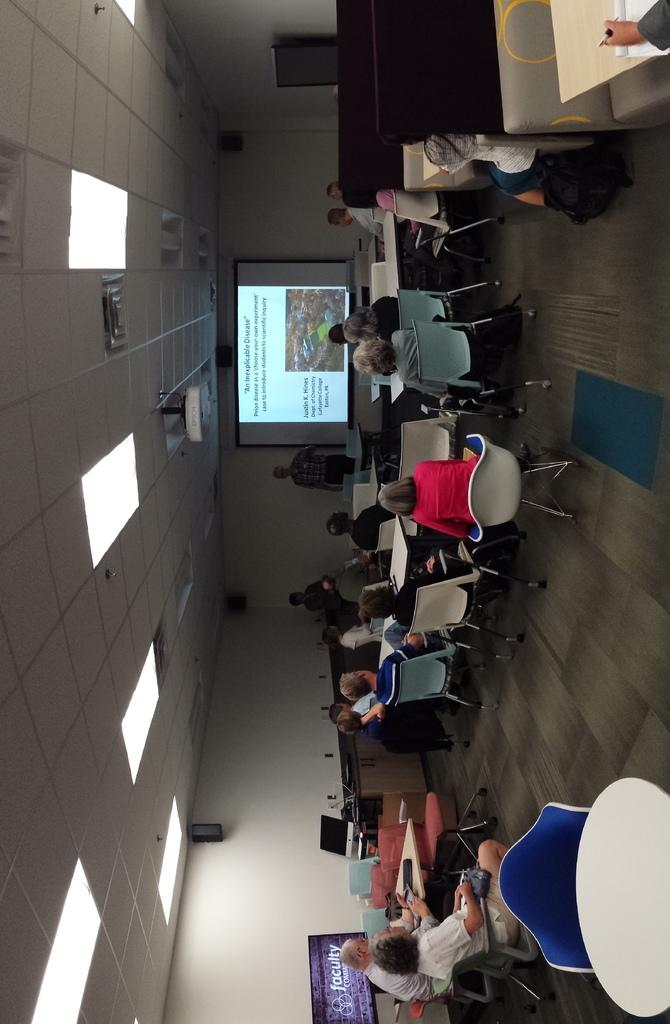<image>
Share a concise interpretation of the image provided. People look at a projector screen about An Inexplicable Disease. 